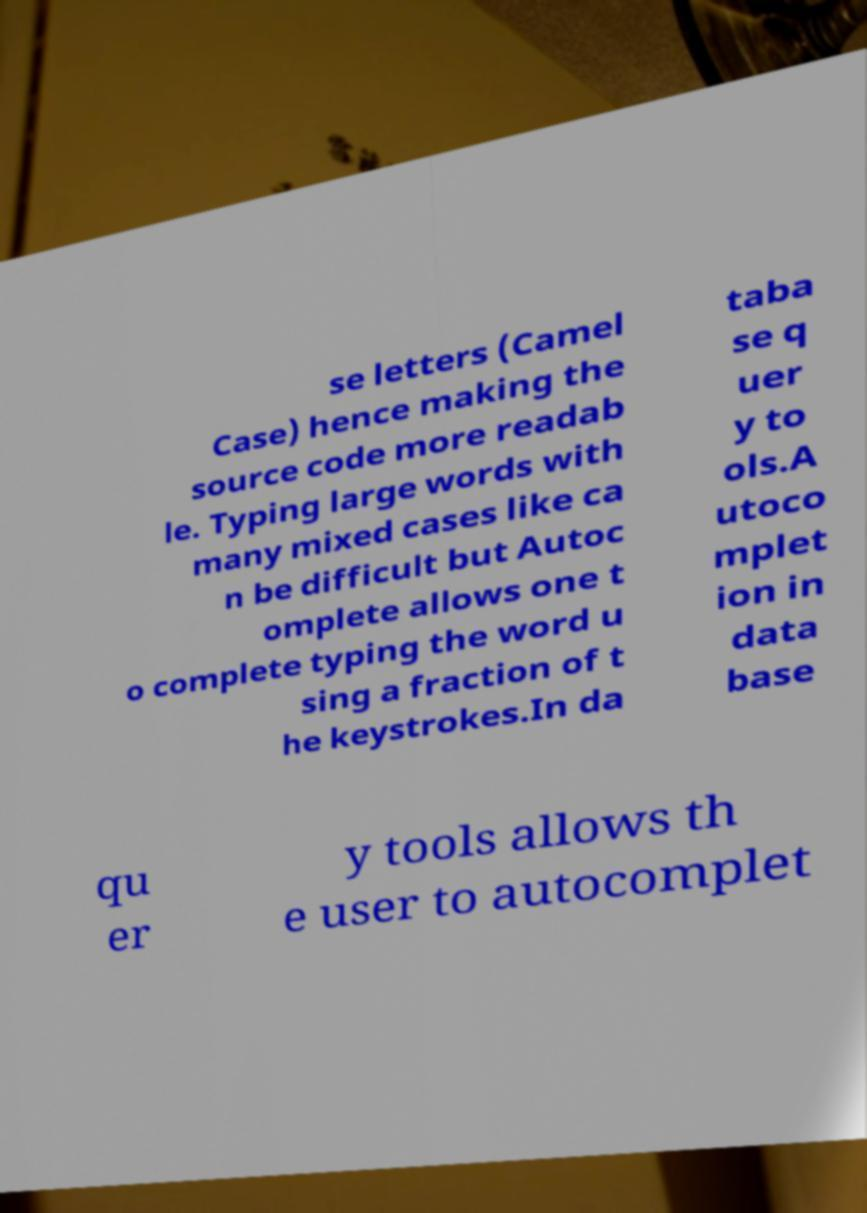Could you assist in decoding the text presented in this image and type it out clearly? se letters (Camel Case) hence making the source code more readab le. Typing large words with many mixed cases like ca n be difficult but Autoc omplete allows one t o complete typing the word u sing a fraction of t he keystrokes.In da taba se q uer y to ols.A utoco mplet ion in data base qu er y tools allows th e user to autocomplet 